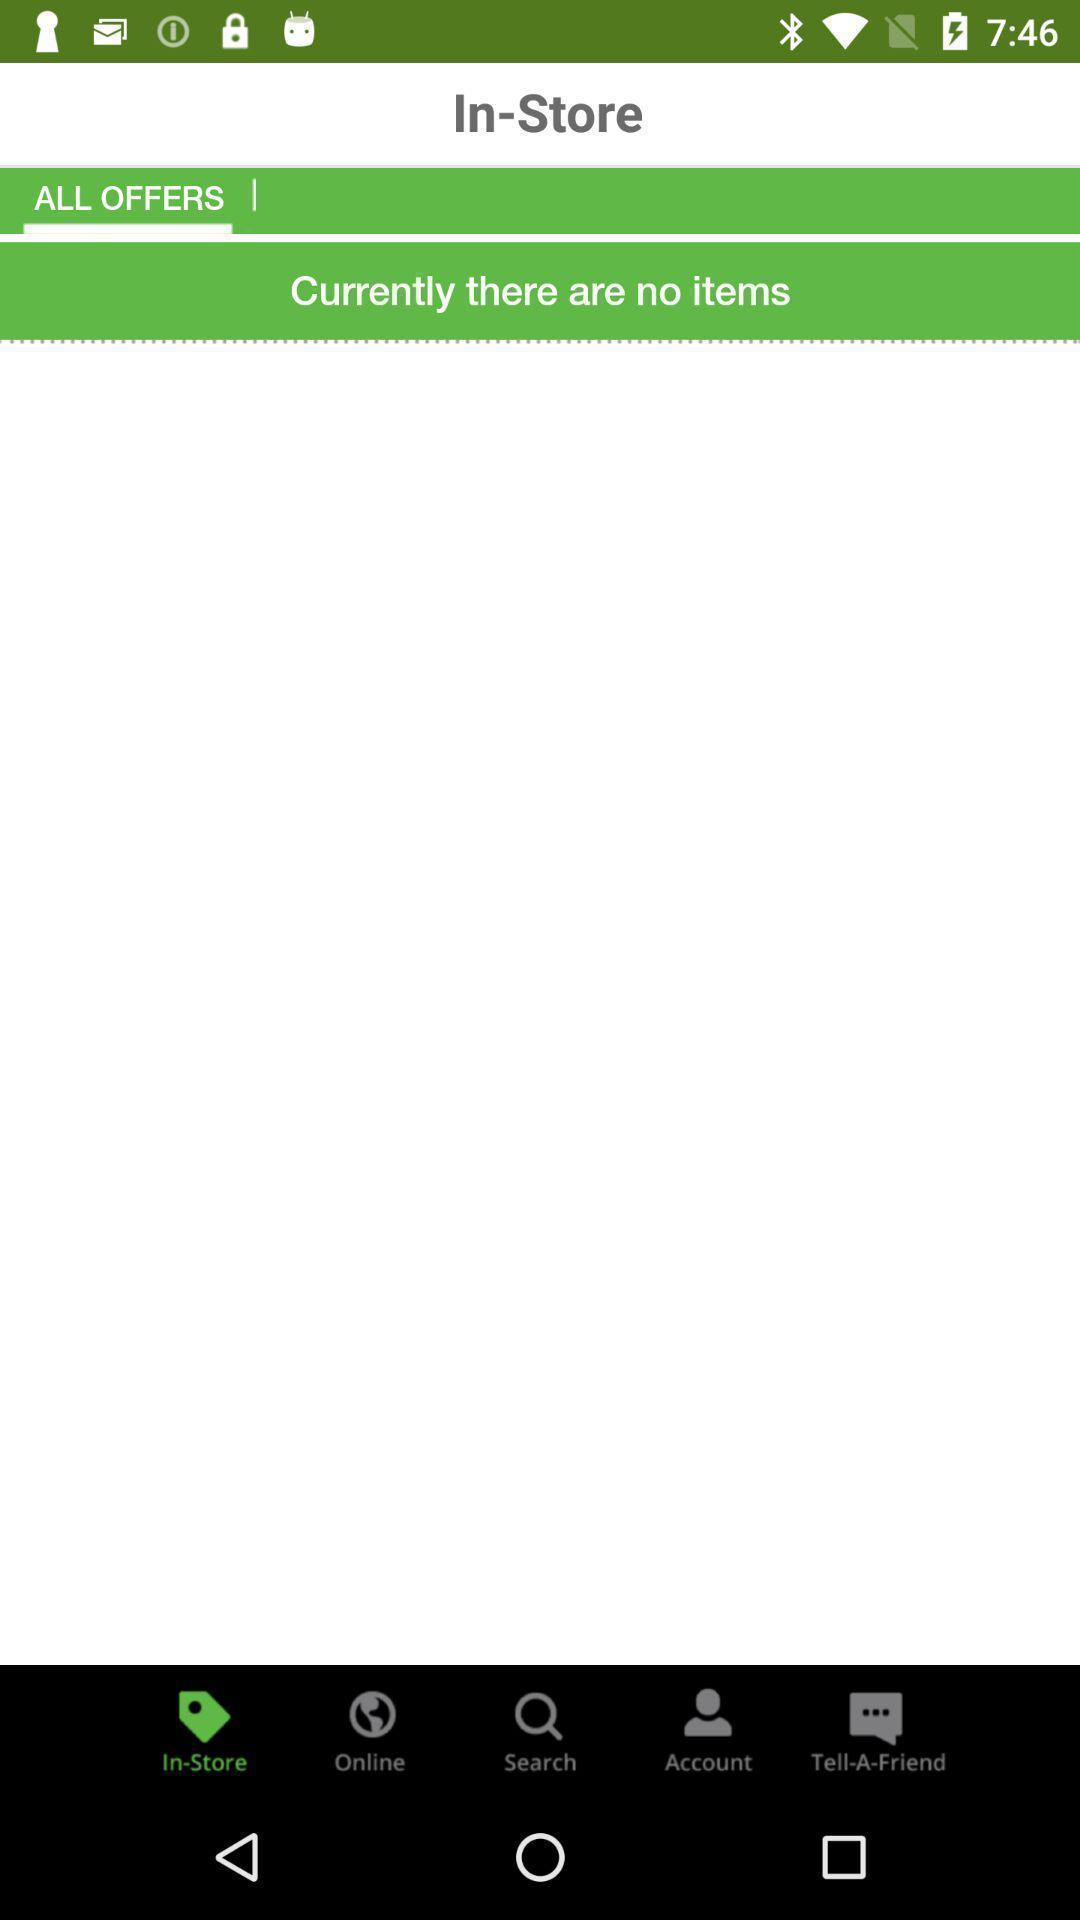Provide a detailed account of this screenshot. Screen shows display page of cashback application. 